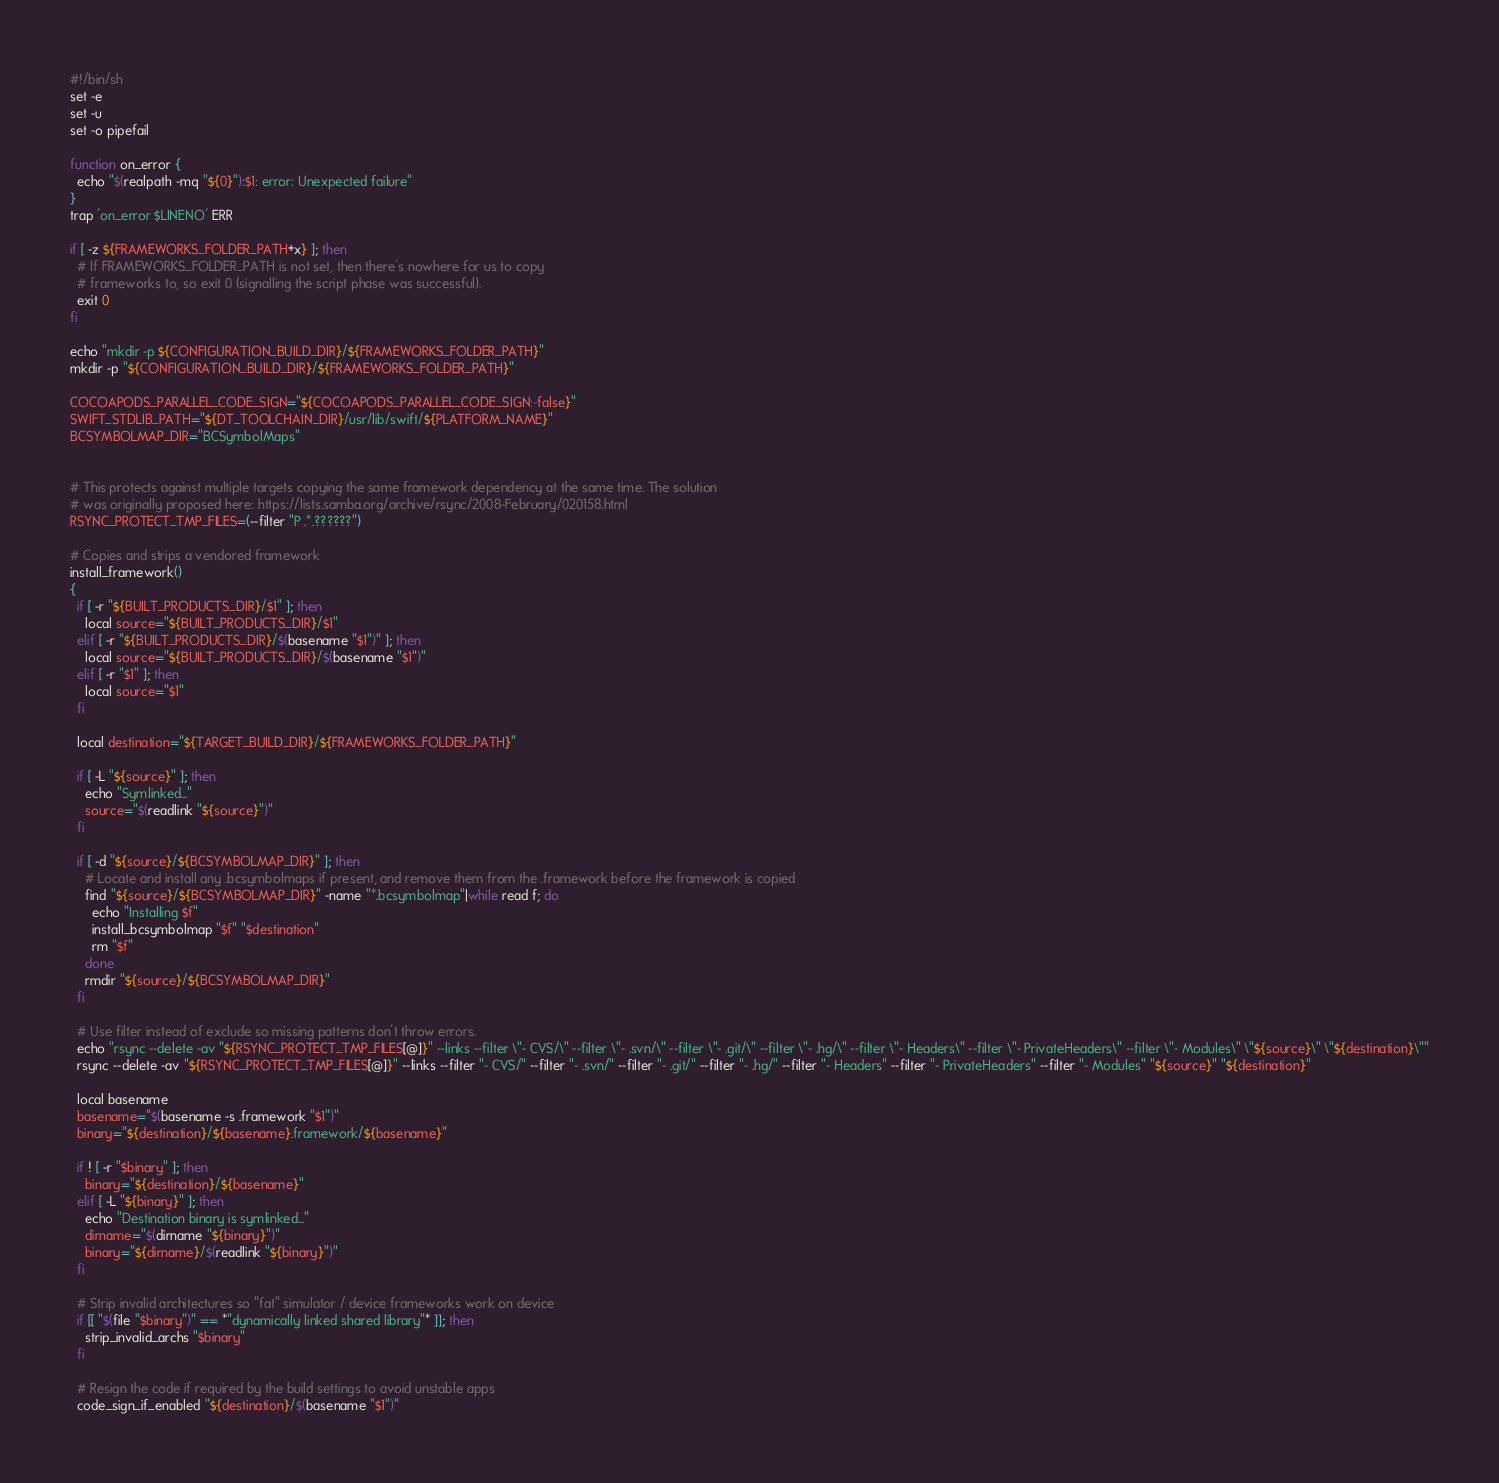Convert code to text. <code><loc_0><loc_0><loc_500><loc_500><_Bash_>#!/bin/sh
set -e
set -u
set -o pipefail

function on_error {
  echo "$(realpath -mq "${0}"):$1: error: Unexpected failure"
}
trap 'on_error $LINENO' ERR

if [ -z ${FRAMEWORKS_FOLDER_PATH+x} ]; then
  # If FRAMEWORKS_FOLDER_PATH is not set, then there's nowhere for us to copy
  # frameworks to, so exit 0 (signalling the script phase was successful).
  exit 0
fi

echo "mkdir -p ${CONFIGURATION_BUILD_DIR}/${FRAMEWORKS_FOLDER_PATH}"
mkdir -p "${CONFIGURATION_BUILD_DIR}/${FRAMEWORKS_FOLDER_PATH}"

COCOAPODS_PARALLEL_CODE_SIGN="${COCOAPODS_PARALLEL_CODE_SIGN:-false}"
SWIFT_STDLIB_PATH="${DT_TOOLCHAIN_DIR}/usr/lib/swift/${PLATFORM_NAME}"
BCSYMBOLMAP_DIR="BCSymbolMaps"


# This protects against multiple targets copying the same framework dependency at the same time. The solution
# was originally proposed here: https://lists.samba.org/archive/rsync/2008-February/020158.html
RSYNC_PROTECT_TMP_FILES=(--filter "P .*.??????")

# Copies and strips a vendored framework
install_framework()
{
  if [ -r "${BUILT_PRODUCTS_DIR}/$1" ]; then
    local source="${BUILT_PRODUCTS_DIR}/$1"
  elif [ -r "${BUILT_PRODUCTS_DIR}/$(basename "$1")" ]; then
    local source="${BUILT_PRODUCTS_DIR}/$(basename "$1")"
  elif [ -r "$1" ]; then
    local source="$1"
  fi

  local destination="${TARGET_BUILD_DIR}/${FRAMEWORKS_FOLDER_PATH}"

  if [ -L "${source}" ]; then
    echo "Symlinked..."
    source="$(readlink "${source}")"
  fi

  if [ -d "${source}/${BCSYMBOLMAP_DIR}" ]; then
    # Locate and install any .bcsymbolmaps if present, and remove them from the .framework before the framework is copied
    find "${source}/${BCSYMBOLMAP_DIR}" -name "*.bcsymbolmap"|while read f; do
      echo "Installing $f"
      install_bcsymbolmap "$f" "$destination"
      rm "$f"
    done
    rmdir "${source}/${BCSYMBOLMAP_DIR}"
  fi

  # Use filter instead of exclude so missing patterns don't throw errors.
  echo "rsync --delete -av "${RSYNC_PROTECT_TMP_FILES[@]}" --links --filter \"- CVS/\" --filter \"- .svn/\" --filter \"- .git/\" --filter \"- .hg/\" --filter \"- Headers\" --filter \"- PrivateHeaders\" --filter \"- Modules\" \"${source}\" \"${destination}\""
  rsync --delete -av "${RSYNC_PROTECT_TMP_FILES[@]}" --links --filter "- CVS/" --filter "- .svn/" --filter "- .git/" --filter "- .hg/" --filter "- Headers" --filter "- PrivateHeaders" --filter "- Modules" "${source}" "${destination}"

  local basename
  basename="$(basename -s .framework "$1")"
  binary="${destination}/${basename}.framework/${basename}"

  if ! [ -r "$binary" ]; then
    binary="${destination}/${basename}"
  elif [ -L "${binary}" ]; then
    echo "Destination binary is symlinked..."
    dirname="$(dirname "${binary}")"
    binary="${dirname}/$(readlink "${binary}")"
  fi

  # Strip invalid architectures so "fat" simulator / device frameworks work on device
  if [[ "$(file "$binary")" == *"dynamically linked shared library"* ]]; then
    strip_invalid_archs "$binary"
  fi

  # Resign the code if required by the build settings to avoid unstable apps
  code_sign_if_enabled "${destination}/$(basename "$1")"
</code> 